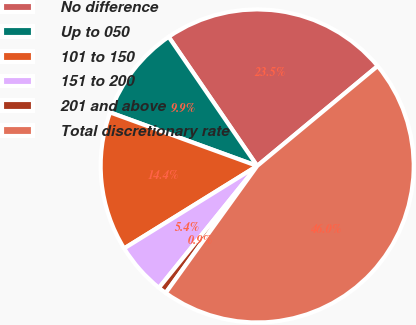<chart> <loc_0><loc_0><loc_500><loc_500><pie_chart><fcel>No difference<fcel>Up to 050<fcel>101 to 150<fcel>151 to 200<fcel>201 and above<fcel>Total discretionary rate<nl><fcel>23.55%<fcel>9.88%<fcel>14.39%<fcel>5.37%<fcel>0.86%<fcel>45.96%<nl></chart> 